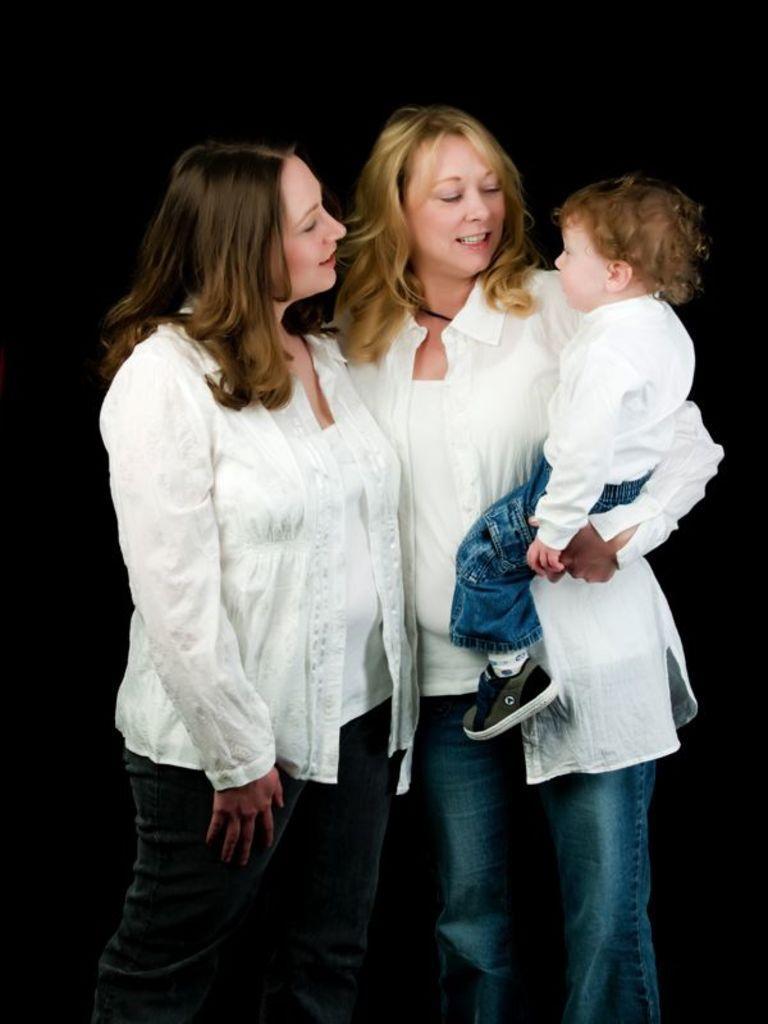How would you summarize this image in a sentence or two? In this image there are two women standing in the middle. The woman on the right side is holding the kid. 